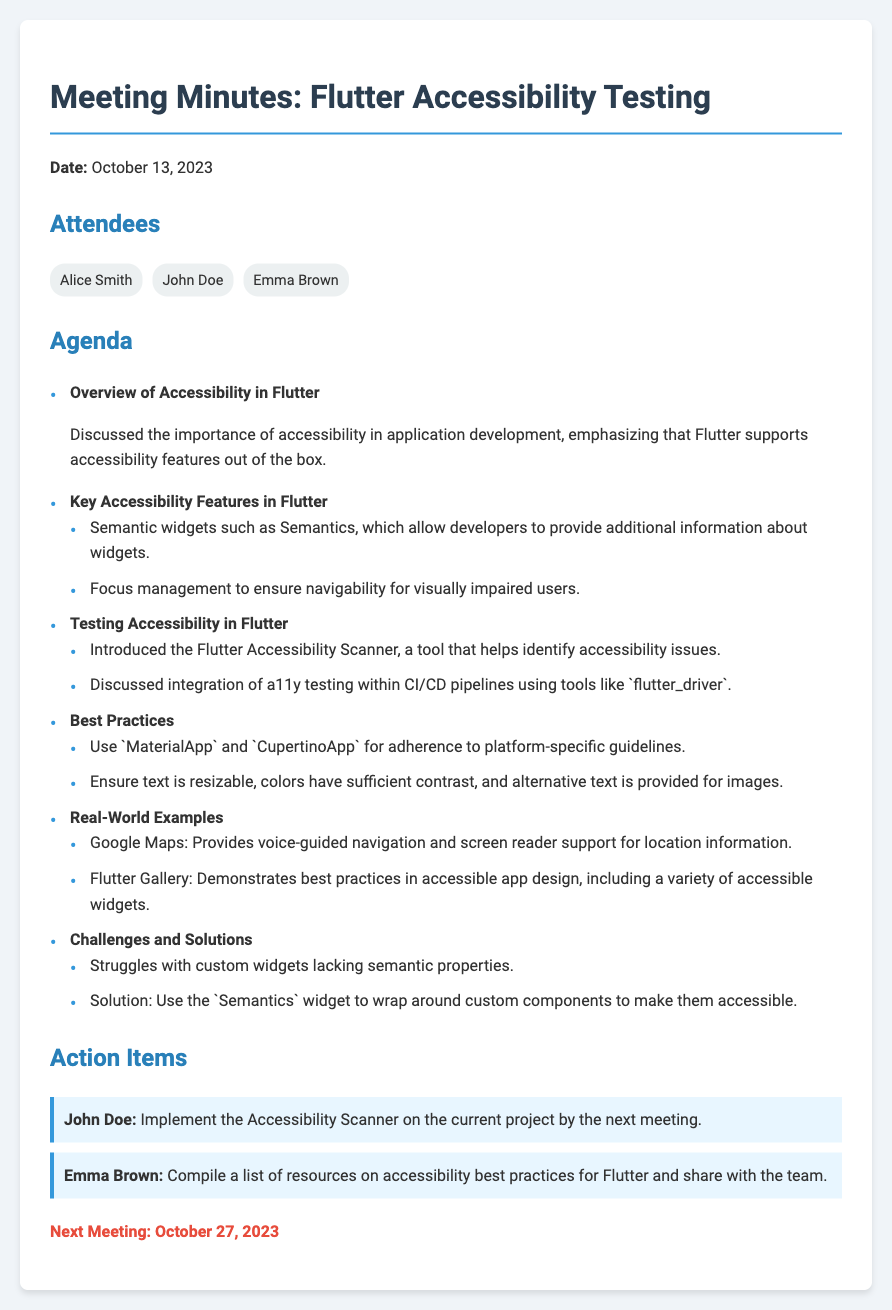what is the date of the meeting? The date of the meeting is mentioned directly in the document under the title.
Answer: October 13, 2023 who is responsible for implementing the Accessibility Scanner? The action item states that John Doe is responsible for implementing the Accessibility Scanner.
Answer: John Doe what are two key accessibility features mentioned? The document lists two specific features under the agenda, prompting us to summarize them.
Answer: Semantic widgets, focus management what is the next meeting date? The next meeting is specified in the closing section of the document.
Answer: October 27, 2023 what solution is proposed for struggles with custom widgets? The challenges section outlines a specific solution to the identified problem.
Answer: Use the Semantics widget how many attendees are listed in the document? The attendees section provides the names of all the members present at the meeting.
Answer: Three what is the purpose of the Flutter Accessibility Scanner? The document provides a brief introduction to this tool's function within the testing discussion.
Answer: Identifies accessibility issues which application is mentioned as an example of accessible design? The real-world examples section explicitly refers to particular applications known for their design.
Answer: Google Maps 